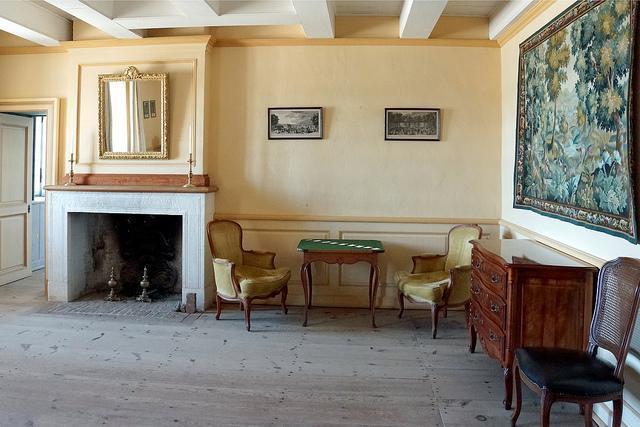How many chairs are in the room?
Give a very brief answer. 3. How many chairs can you see?
Give a very brief answer. 3. 